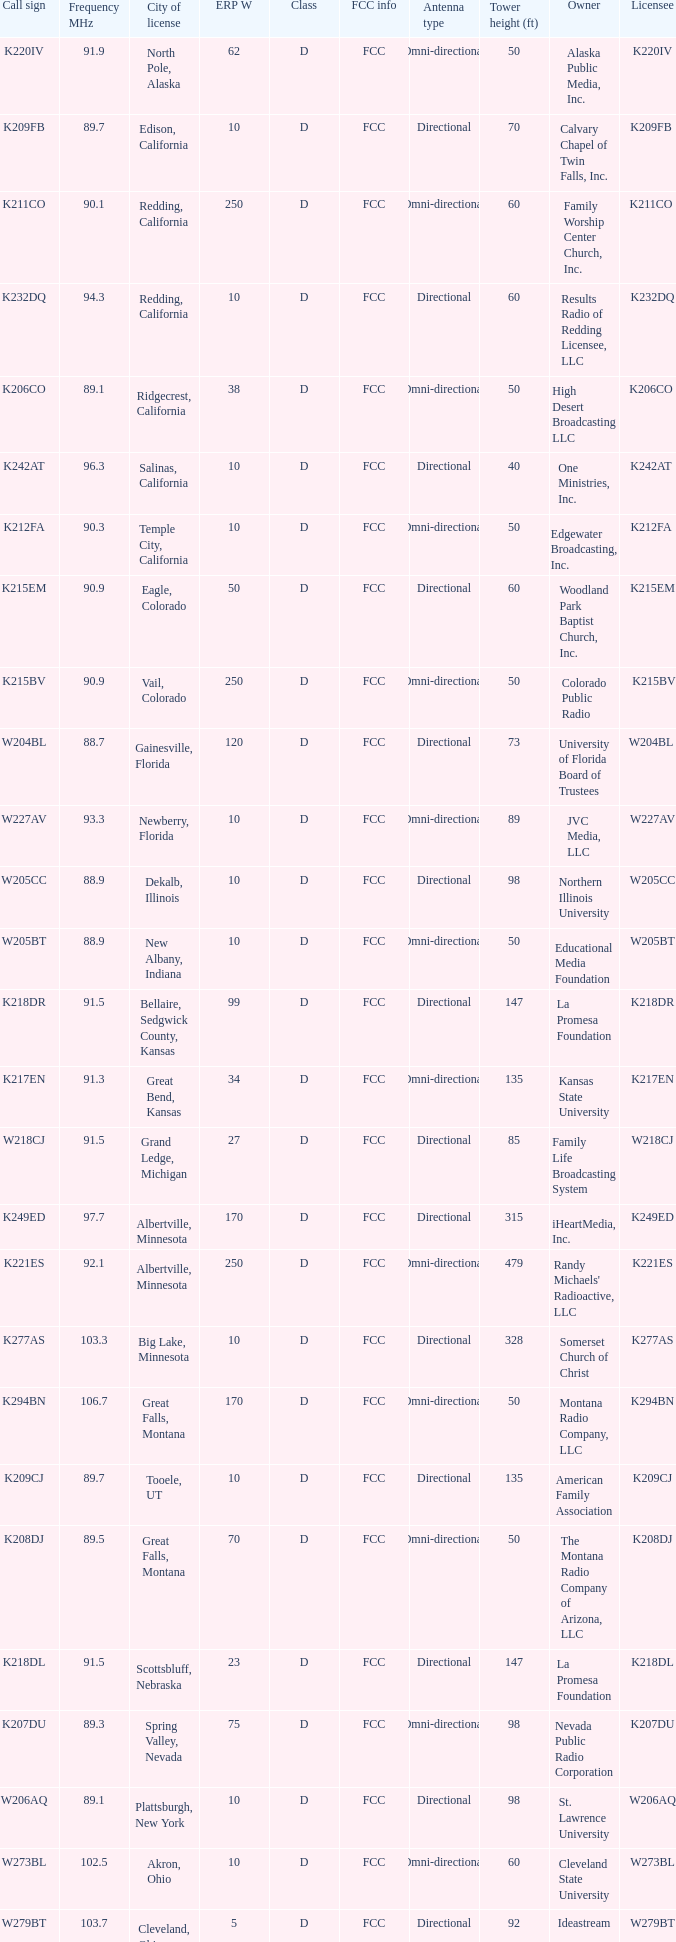What is the highest ERP W of an 89.1 frequency translator? 38.0. 